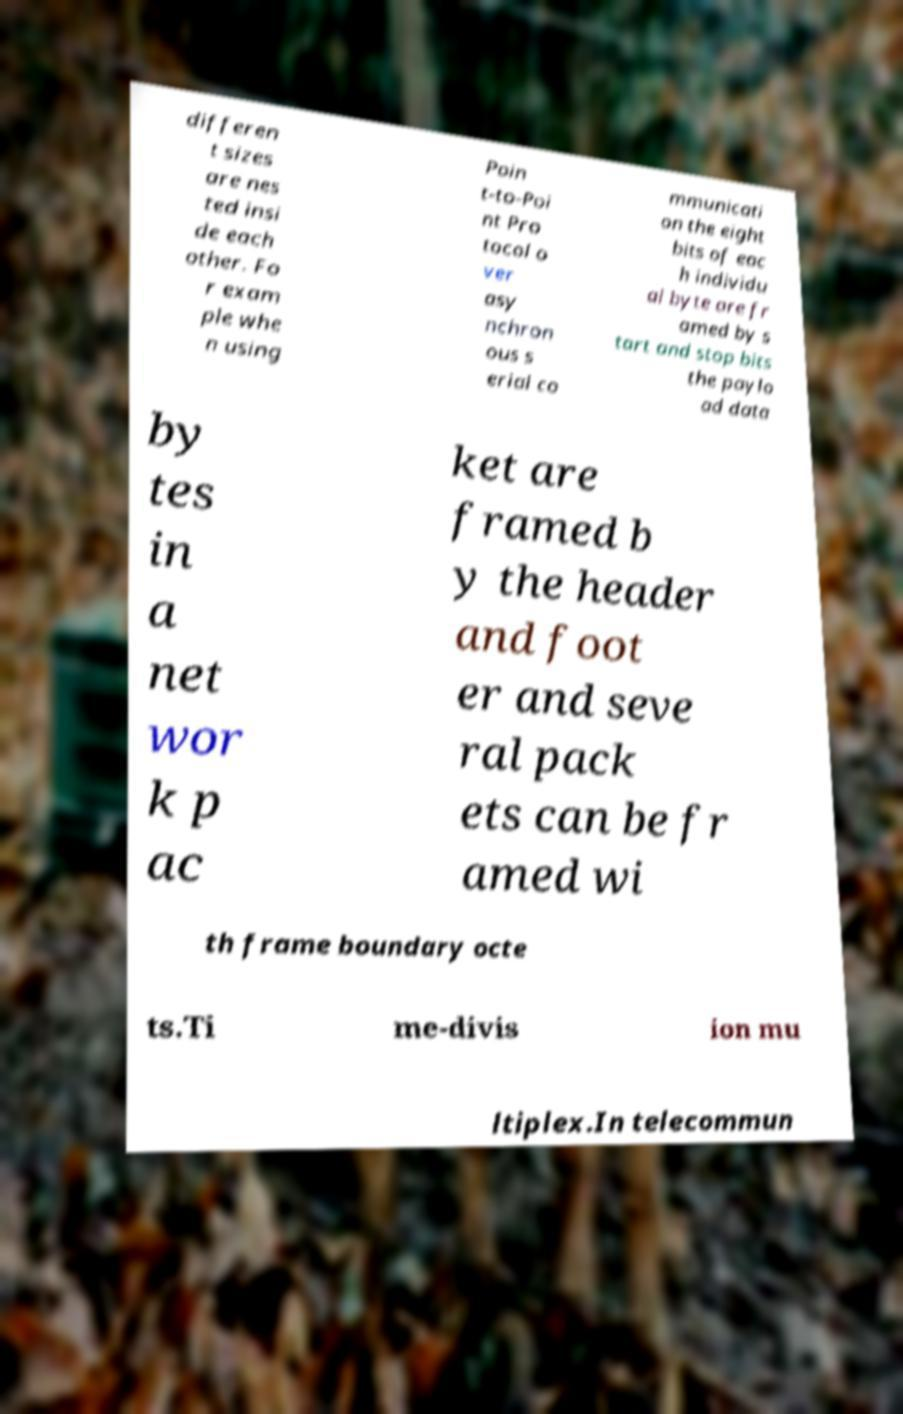What messages or text are displayed in this image? I need them in a readable, typed format. differen t sizes are nes ted insi de each other. Fo r exam ple whe n using Poin t-to-Poi nt Pro tocol o ver asy nchron ous s erial co mmunicati on the eight bits of eac h individu al byte are fr amed by s tart and stop bits the paylo ad data by tes in a net wor k p ac ket are framed b y the header and foot er and seve ral pack ets can be fr amed wi th frame boundary octe ts.Ti me-divis ion mu ltiplex.In telecommun 